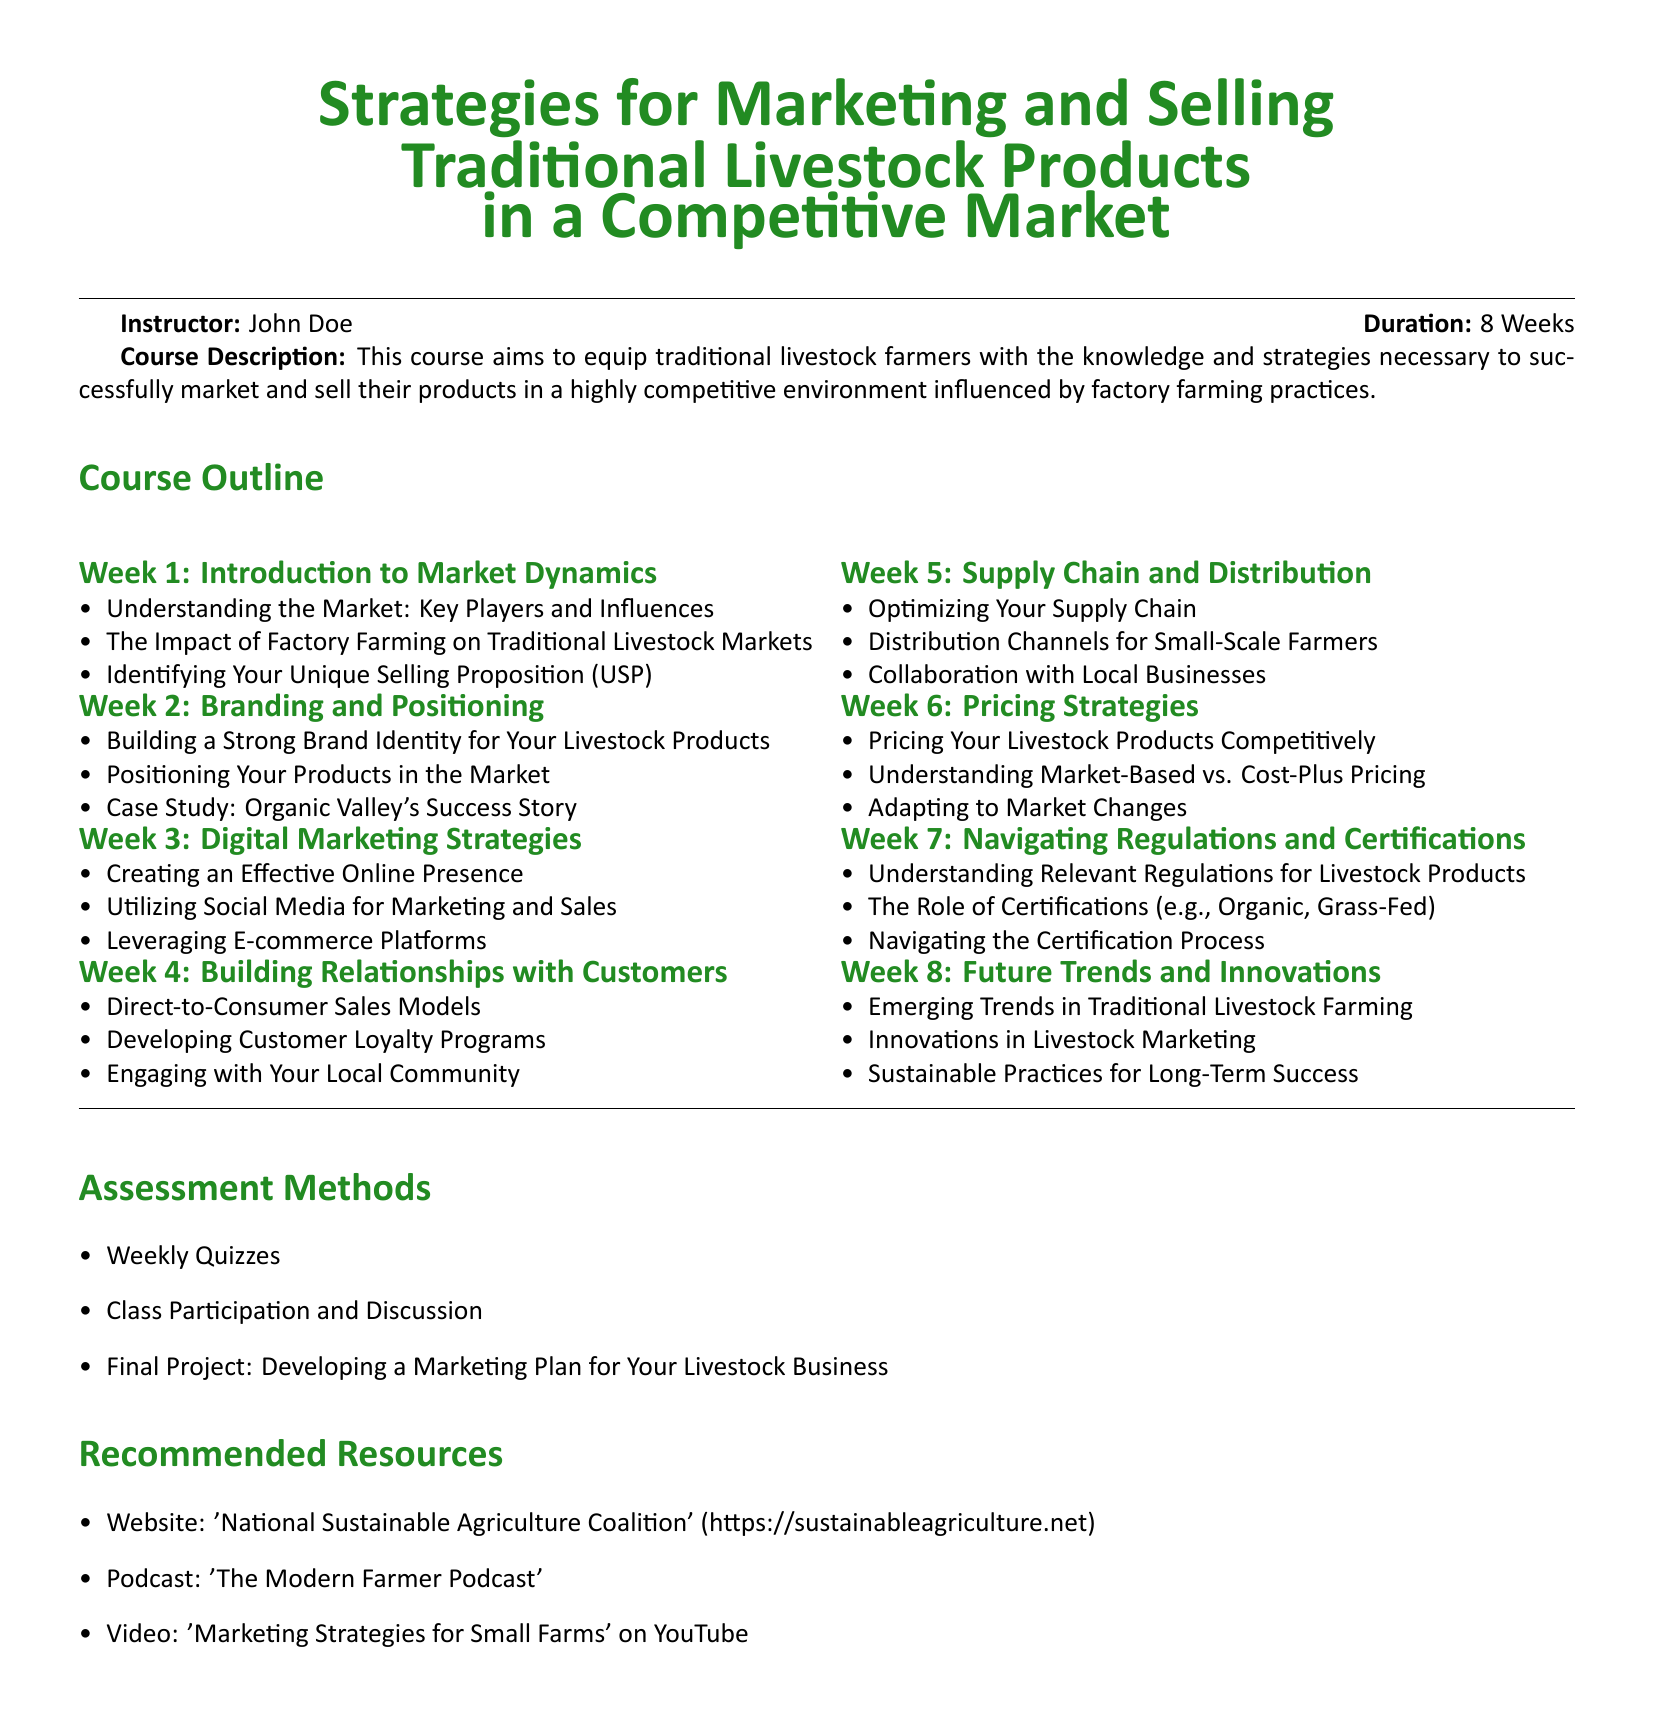what is the duration of the course? The duration of the course is explicitly stated in the document as eight weeks.
Answer: 8 Weeks who is the instructor for the course? The instructor's name is listed in the document under the instructor section.
Answer: John Doe what is the title of the course? The title of the course is presented prominently at the beginning of the document.
Answer: Strategies for Marketing and Selling Traditional Livestock Products in a Competitive Market what week focuses on Branding and Positioning? The specific week that covers branding and positioning is listed in the course outline.
Answer: Week 2 name one recommended resource for the course. The document provides a list of recommended resources, any one of which can be an answer.
Answer: National Sustainable Agriculture Coalition how many weeks are dedicated to Digital Marketing Strategies? The total number of weeks related to Digital Marketing Strategies can be found in the course outline.
Answer: 1 Week what is the main purpose of this course? The purpose of the course is explained in the course description section.
Answer: Equip traditional livestock farmers with knowledge and strategies which week discusses Future Trends and Innovations? The week that discusses future trends and innovations is mentioned in the course outline.
Answer: Week 8 